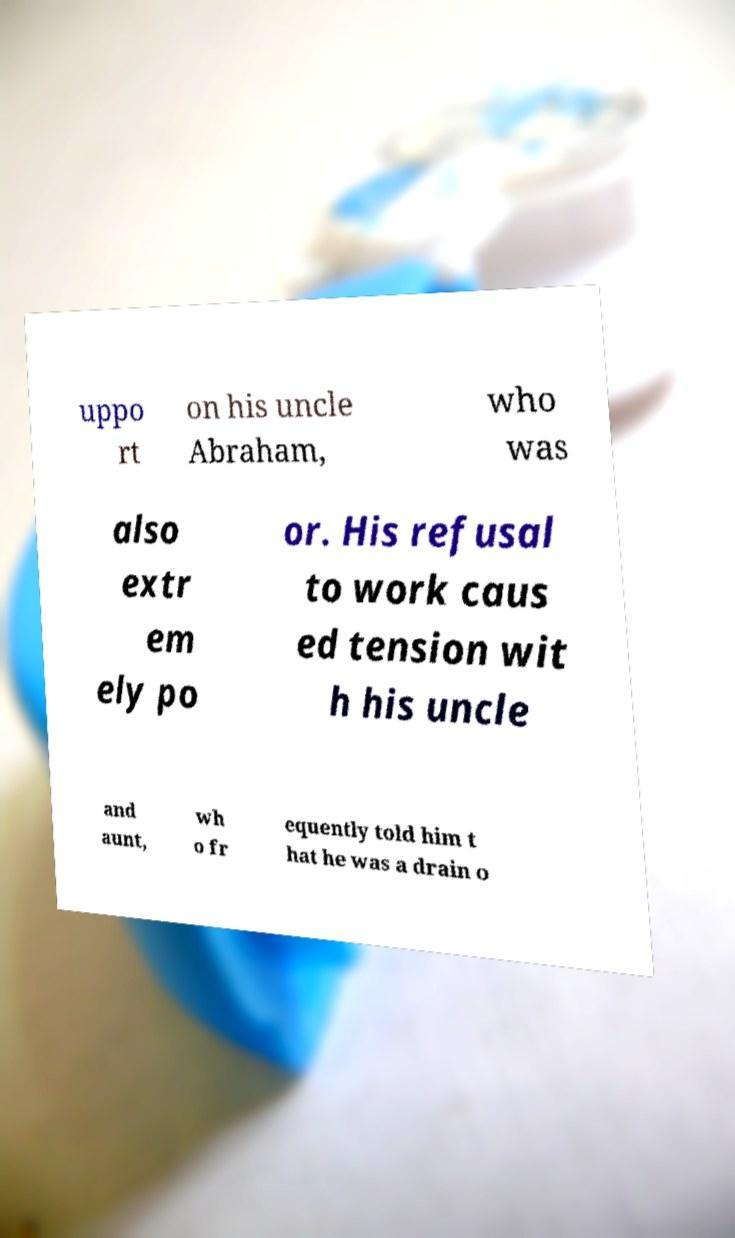Can you read and provide the text displayed in the image?This photo seems to have some interesting text. Can you extract and type it out for me? uppo rt on his uncle Abraham, who was also extr em ely po or. His refusal to work caus ed tension wit h his uncle and aunt, wh o fr equently told him t hat he was a drain o 